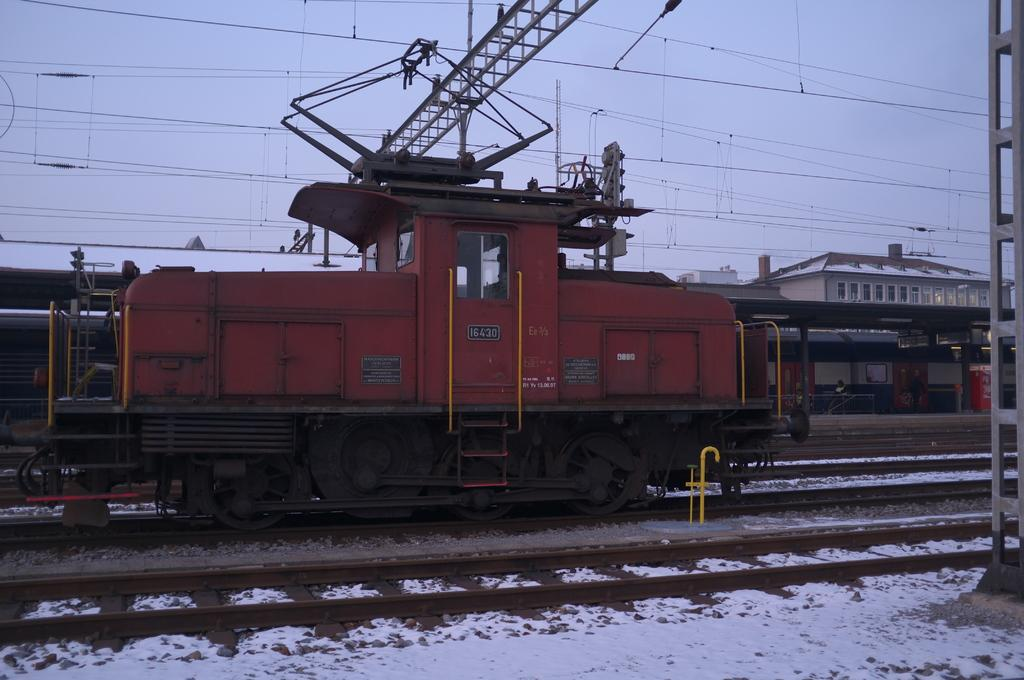What is the main subject of the image? The main subject of the image is a train engine. Can you describe the train in the image? Yes, there is a train in the image, and it is connected to the train engine. What can be seen beneath the train? There are tracks in the image, which the train is running on. What type of structures are present in the image? There are beams, a building, and an open-shed visible in the image. What is visible in the background of the image? The sky is visible in the image. Are there any other objects present in the image? Yes, there are objects in the image, but their specific details are not mentioned in the provided facts. What type of salt can be seen on the train tracks in the image? There is no salt present on the train tracks in the image. 